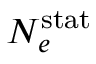<formula> <loc_0><loc_0><loc_500><loc_500>N _ { e } ^ { s t a t }</formula> 